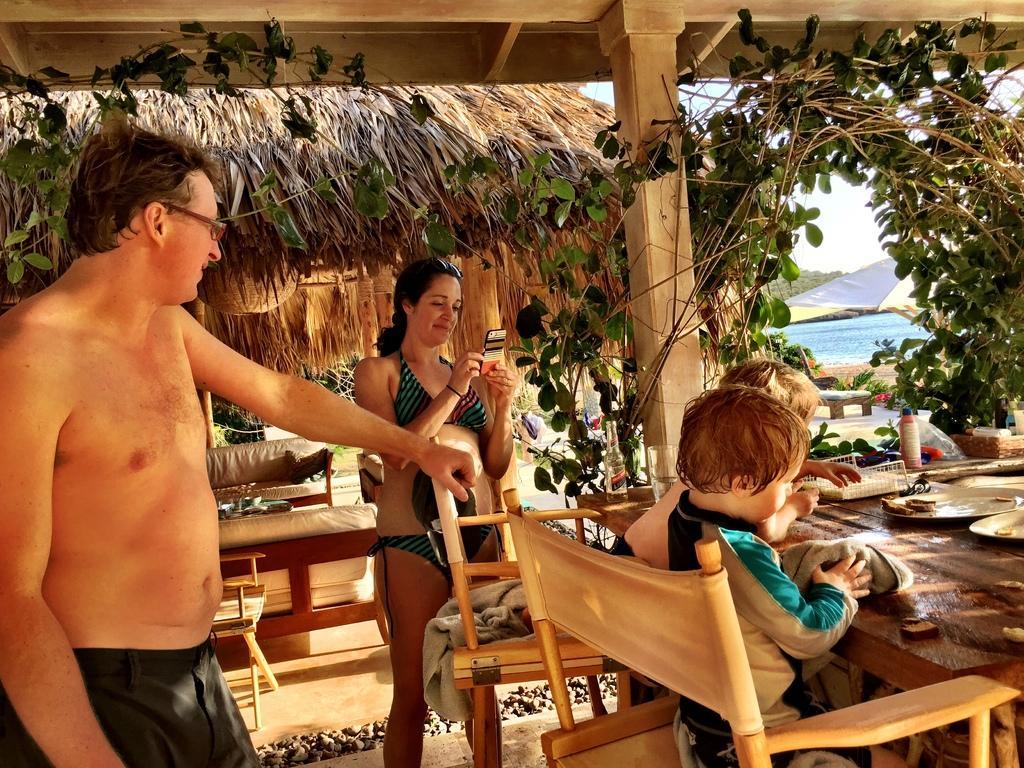In one or two sentences, can you explain what this image depicts? In this image there is a man , woman standing near the chair , there are 2 babies sitting in chair and in table there is plate, food, bottle and in back ground there is plants, trees, beach , umbrella,sky. 